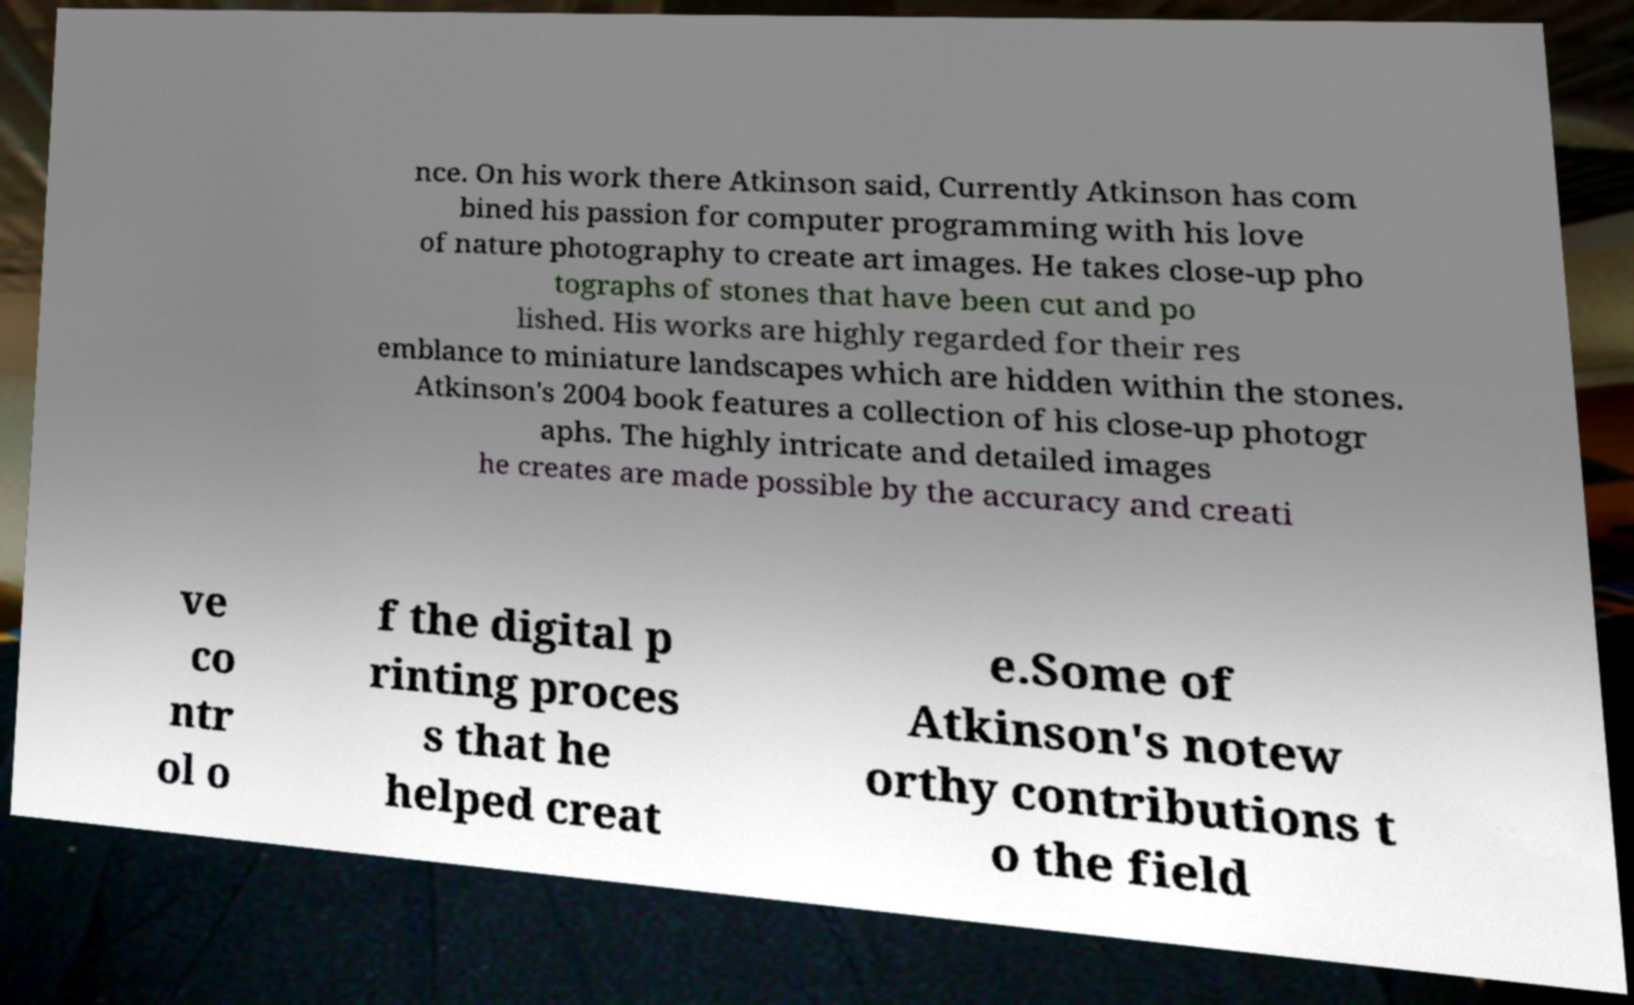Could you extract and type out the text from this image? nce. On his work there Atkinson said, Currently Atkinson has com bined his passion for computer programming with his love of nature photography to create art images. He takes close-up pho tographs of stones that have been cut and po lished. His works are highly regarded for their res emblance to miniature landscapes which are hidden within the stones. Atkinson's 2004 book features a collection of his close-up photogr aphs. The highly intricate and detailed images he creates are made possible by the accuracy and creati ve co ntr ol o f the digital p rinting proces s that he helped creat e.Some of Atkinson's notew orthy contributions t o the field 